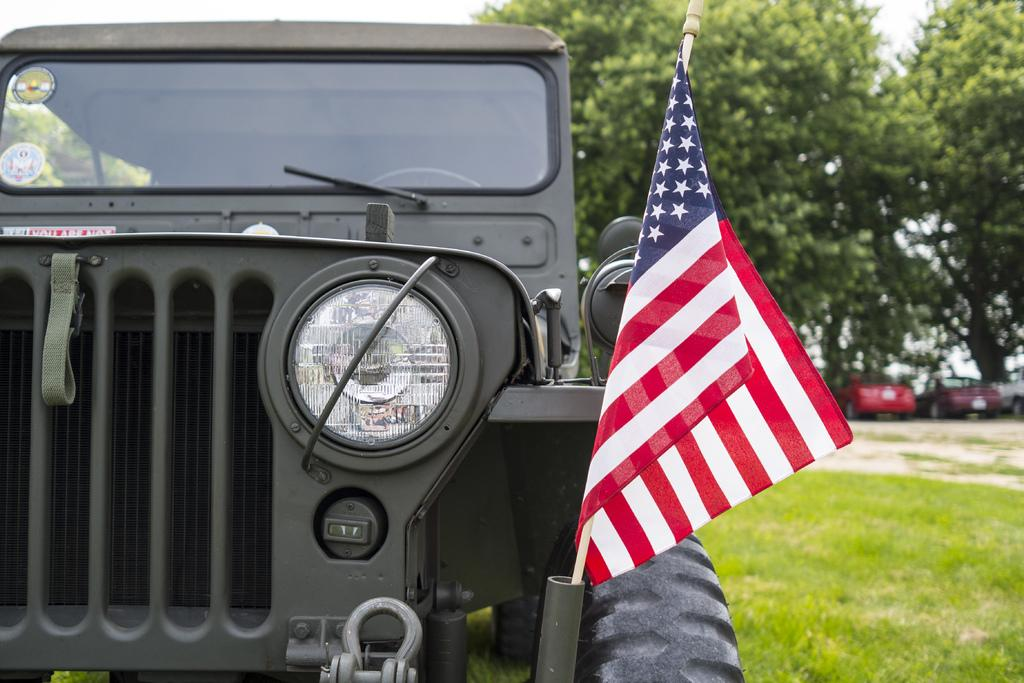What is the main subject of the image? The main subject of the image is a vehicle. What distinguishes this vehicle from others in the image? This vehicle has a flag on it. Where is the vehicle located? The vehicle is on the grass. Are there any additional markings or features on the vehicle? Yes, there are two stickers on the glass of the vehicle. What can be seen in the background of the image? The background of the image is blurry, but trees are visible. How many vehicles are present in the image? There are other vehicles in the image, in addition to the one with the flag. What advice does the letter on the vehicle provide? There is no letter present on the vehicle, so no advice can be given. 